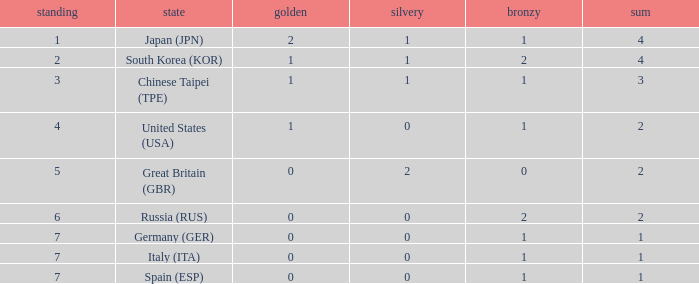What is the rank of the country with more than 2 medals, and 2 gold medals? 1.0. Write the full table. {'header': ['standing', 'state', 'golden', 'silvery', 'bronzy', 'sum'], 'rows': [['1', 'Japan (JPN)', '2', '1', '1', '4'], ['2', 'South Korea (KOR)', '1', '1', '2', '4'], ['3', 'Chinese Taipei (TPE)', '1', '1', '1', '3'], ['4', 'United States (USA)', '1', '0', '1', '2'], ['5', 'Great Britain (GBR)', '0', '2', '0', '2'], ['6', 'Russia (RUS)', '0', '0', '2', '2'], ['7', 'Germany (GER)', '0', '0', '1', '1'], ['7', 'Italy (ITA)', '0', '0', '1', '1'], ['7', 'Spain (ESP)', '0', '0', '1', '1']]} 